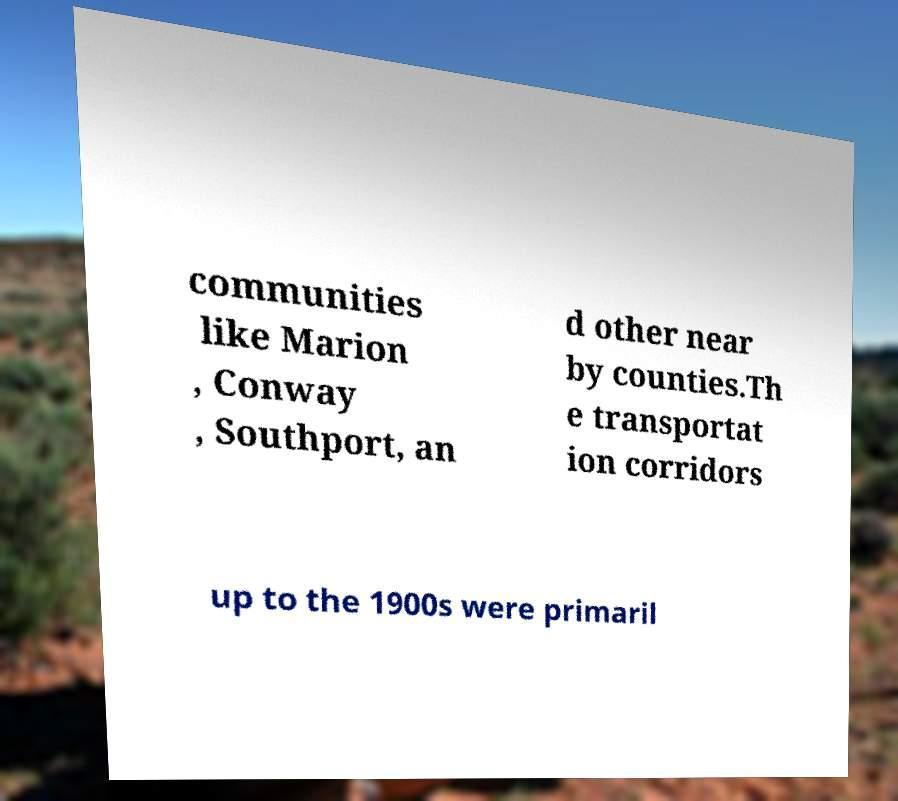Can you read and provide the text displayed in the image?This photo seems to have some interesting text. Can you extract and type it out for me? communities like Marion , Conway , Southport, an d other near by counties.Th e transportat ion corridors up to the 1900s were primaril 